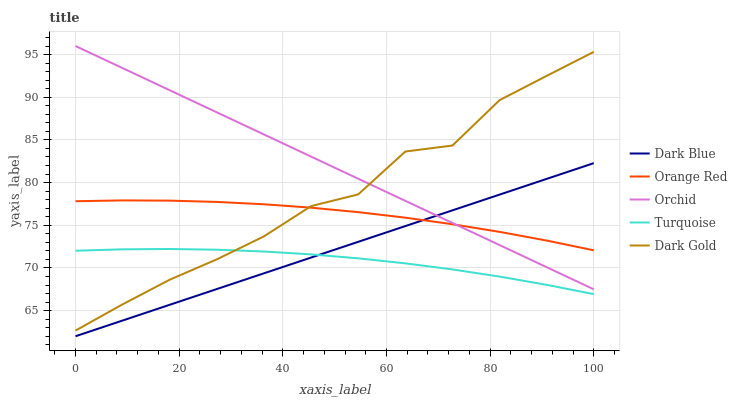Does Dark Gold have the minimum area under the curve?
Answer yes or no. No. Does Dark Gold have the maximum area under the curve?
Answer yes or no. No. Is Turquoise the smoothest?
Answer yes or no. No. Is Turquoise the roughest?
Answer yes or no. No. Does Turquoise have the lowest value?
Answer yes or no. No. Does Dark Gold have the highest value?
Answer yes or no. No. Is Dark Blue less than Dark Gold?
Answer yes or no. Yes. Is Dark Gold greater than Dark Blue?
Answer yes or no. Yes. Does Dark Blue intersect Dark Gold?
Answer yes or no. No. 